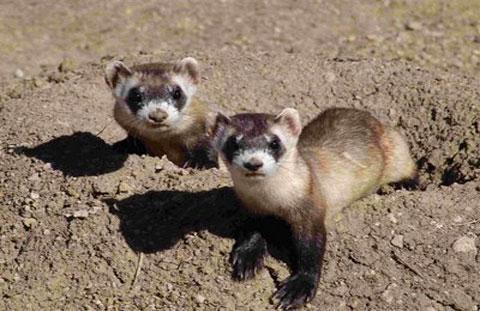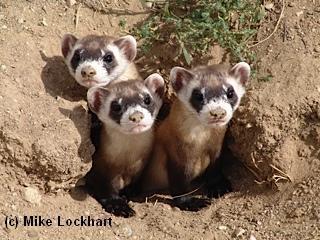The first image is the image on the left, the second image is the image on the right. Assess this claim about the two images: "There are at most two ferrets.". Correct or not? Answer yes or no. No. The first image is the image on the left, the second image is the image on the right. Analyze the images presented: Is the assertion "There are at least three total rodents." valid? Answer yes or no. Yes. 